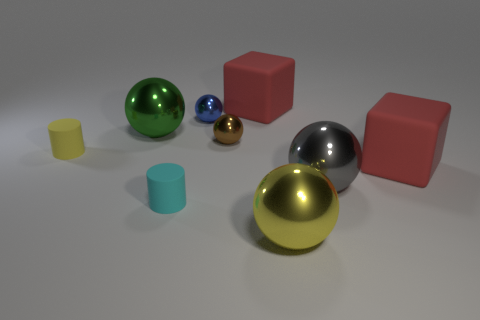Subtract all small brown spheres. How many spheres are left? 4 Add 1 blue balls. How many objects exist? 10 Subtract all green spheres. How many spheres are left? 4 Subtract all cylinders. How many objects are left? 7 Subtract 1 blocks. How many blocks are left? 1 Subtract all gray balls. Subtract all green blocks. How many balls are left? 4 Subtract all yellow objects. Subtract all cylinders. How many objects are left? 5 Add 7 brown metal balls. How many brown metal balls are left? 8 Add 4 cyan rubber objects. How many cyan rubber objects exist? 5 Subtract 0 purple balls. How many objects are left? 9 